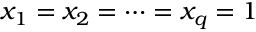Convert formula to latex. <formula><loc_0><loc_0><loc_500><loc_500>x _ { 1 } = x _ { 2 } = \dots = x _ { q } = 1</formula> 